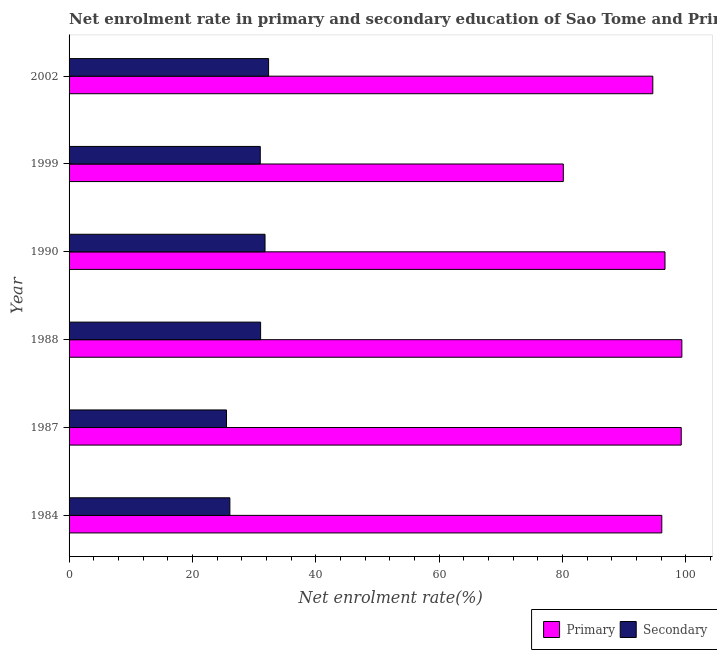How many groups of bars are there?
Offer a terse response. 6. How many bars are there on the 2nd tick from the top?
Your response must be concise. 2. In how many cases, is the number of bars for a given year not equal to the number of legend labels?
Keep it short and to the point. 0. What is the enrollment rate in secondary education in 1990?
Your response must be concise. 31.78. Across all years, what is the maximum enrollment rate in primary education?
Your response must be concise. 99.38. Across all years, what is the minimum enrollment rate in primary education?
Provide a succinct answer. 80.15. In which year was the enrollment rate in secondary education minimum?
Ensure brevity in your answer.  1987. What is the total enrollment rate in secondary education in the graph?
Offer a terse response. 177.82. What is the difference between the enrollment rate in primary education in 1984 and that in 1988?
Your response must be concise. -3.25. What is the difference between the enrollment rate in secondary education in 1984 and the enrollment rate in primary education in 1987?
Offer a terse response. -73.2. What is the average enrollment rate in secondary education per year?
Your answer should be compact. 29.64. In the year 1984, what is the difference between the enrollment rate in primary education and enrollment rate in secondary education?
Provide a succinct answer. 70.05. Is the enrollment rate in primary education in 1984 less than that in 1990?
Ensure brevity in your answer.  Yes. Is the difference between the enrollment rate in secondary education in 1990 and 1999 greater than the difference between the enrollment rate in primary education in 1990 and 1999?
Offer a terse response. No. What is the difference between the highest and the lowest enrollment rate in secondary education?
Your response must be concise. 6.83. What does the 2nd bar from the top in 1990 represents?
Offer a very short reply. Primary. What does the 2nd bar from the bottom in 1984 represents?
Offer a very short reply. Secondary. How many years are there in the graph?
Keep it short and to the point. 6. What is the difference between two consecutive major ticks on the X-axis?
Your response must be concise. 20. Does the graph contain any zero values?
Provide a succinct answer. No. Does the graph contain grids?
Ensure brevity in your answer.  No. How are the legend labels stacked?
Your answer should be compact. Horizontal. What is the title of the graph?
Offer a very short reply. Net enrolment rate in primary and secondary education of Sao Tome and Principe. Does "Girls" appear as one of the legend labels in the graph?
Ensure brevity in your answer.  No. What is the label or title of the X-axis?
Provide a succinct answer. Net enrolment rate(%). What is the label or title of the Y-axis?
Your answer should be compact. Year. What is the Net enrolment rate(%) in Primary in 1984?
Provide a short and direct response. 96.13. What is the Net enrolment rate(%) in Secondary in 1984?
Offer a very short reply. 26.08. What is the Net enrolment rate(%) of Primary in 1987?
Your response must be concise. 99.28. What is the Net enrolment rate(%) in Secondary in 1987?
Give a very brief answer. 25.53. What is the Net enrolment rate(%) in Primary in 1988?
Your answer should be compact. 99.38. What is the Net enrolment rate(%) of Secondary in 1988?
Keep it short and to the point. 31.06. What is the Net enrolment rate(%) of Primary in 1990?
Make the answer very short. 96.65. What is the Net enrolment rate(%) of Secondary in 1990?
Make the answer very short. 31.78. What is the Net enrolment rate(%) of Primary in 1999?
Keep it short and to the point. 80.15. What is the Net enrolment rate(%) of Secondary in 1999?
Keep it short and to the point. 31.01. What is the Net enrolment rate(%) of Primary in 2002?
Offer a terse response. 94.67. What is the Net enrolment rate(%) in Secondary in 2002?
Offer a very short reply. 32.36. Across all years, what is the maximum Net enrolment rate(%) in Primary?
Give a very brief answer. 99.38. Across all years, what is the maximum Net enrolment rate(%) in Secondary?
Offer a very short reply. 32.36. Across all years, what is the minimum Net enrolment rate(%) in Primary?
Provide a succinct answer. 80.15. Across all years, what is the minimum Net enrolment rate(%) of Secondary?
Provide a succinct answer. 25.53. What is the total Net enrolment rate(%) in Primary in the graph?
Offer a very short reply. 566.25. What is the total Net enrolment rate(%) in Secondary in the graph?
Offer a terse response. 177.82. What is the difference between the Net enrolment rate(%) in Primary in 1984 and that in 1987?
Offer a very short reply. -3.15. What is the difference between the Net enrolment rate(%) of Secondary in 1984 and that in 1987?
Offer a very short reply. 0.55. What is the difference between the Net enrolment rate(%) in Primary in 1984 and that in 1988?
Make the answer very short. -3.25. What is the difference between the Net enrolment rate(%) of Secondary in 1984 and that in 1988?
Ensure brevity in your answer.  -4.98. What is the difference between the Net enrolment rate(%) of Primary in 1984 and that in 1990?
Provide a short and direct response. -0.52. What is the difference between the Net enrolment rate(%) in Secondary in 1984 and that in 1990?
Make the answer very short. -5.7. What is the difference between the Net enrolment rate(%) in Primary in 1984 and that in 1999?
Provide a short and direct response. 15.97. What is the difference between the Net enrolment rate(%) in Secondary in 1984 and that in 1999?
Provide a short and direct response. -4.93. What is the difference between the Net enrolment rate(%) in Primary in 1984 and that in 2002?
Your answer should be very brief. 1.46. What is the difference between the Net enrolment rate(%) of Secondary in 1984 and that in 2002?
Keep it short and to the point. -6.28. What is the difference between the Net enrolment rate(%) in Primary in 1987 and that in 1988?
Your answer should be compact. -0.1. What is the difference between the Net enrolment rate(%) in Secondary in 1987 and that in 1988?
Offer a terse response. -5.53. What is the difference between the Net enrolment rate(%) of Primary in 1987 and that in 1990?
Offer a very short reply. 2.63. What is the difference between the Net enrolment rate(%) of Secondary in 1987 and that in 1990?
Provide a succinct answer. -6.25. What is the difference between the Net enrolment rate(%) of Primary in 1987 and that in 1999?
Your answer should be very brief. 19.13. What is the difference between the Net enrolment rate(%) in Secondary in 1987 and that in 1999?
Offer a very short reply. -5.48. What is the difference between the Net enrolment rate(%) of Primary in 1987 and that in 2002?
Your response must be concise. 4.61. What is the difference between the Net enrolment rate(%) in Secondary in 1987 and that in 2002?
Your response must be concise. -6.83. What is the difference between the Net enrolment rate(%) in Primary in 1988 and that in 1990?
Make the answer very short. 2.73. What is the difference between the Net enrolment rate(%) of Secondary in 1988 and that in 1990?
Give a very brief answer. -0.72. What is the difference between the Net enrolment rate(%) in Primary in 1988 and that in 1999?
Offer a terse response. 19.22. What is the difference between the Net enrolment rate(%) of Secondary in 1988 and that in 1999?
Give a very brief answer. 0.05. What is the difference between the Net enrolment rate(%) of Primary in 1988 and that in 2002?
Your answer should be compact. 4.71. What is the difference between the Net enrolment rate(%) in Secondary in 1988 and that in 2002?
Your answer should be very brief. -1.3. What is the difference between the Net enrolment rate(%) of Primary in 1990 and that in 1999?
Offer a terse response. 16.49. What is the difference between the Net enrolment rate(%) in Secondary in 1990 and that in 1999?
Make the answer very short. 0.77. What is the difference between the Net enrolment rate(%) in Primary in 1990 and that in 2002?
Offer a very short reply. 1.98. What is the difference between the Net enrolment rate(%) in Secondary in 1990 and that in 2002?
Your answer should be very brief. -0.58. What is the difference between the Net enrolment rate(%) in Primary in 1999 and that in 2002?
Offer a terse response. -14.52. What is the difference between the Net enrolment rate(%) of Secondary in 1999 and that in 2002?
Make the answer very short. -1.35. What is the difference between the Net enrolment rate(%) in Primary in 1984 and the Net enrolment rate(%) in Secondary in 1987?
Provide a short and direct response. 70.6. What is the difference between the Net enrolment rate(%) in Primary in 1984 and the Net enrolment rate(%) in Secondary in 1988?
Offer a very short reply. 65.06. What is the difference between the Net enrolment rate(%) of Primary in 1984 and the Net enrolment rate(%) of Secondary in 1990?
Your response must be concise. 64.35. What is the difference between the Net enrolment rate(%) in Primary in 1984 and the Net enrolment rate(%) in Secondary in 1999?
Offer a terse response. 65.12. What is the difference between the Net enrolment rate(%) of Primary in 1984 and the Net enrolment rate(%) of Secondary in 2002?
Offer a very short reply. 63.77. What is the difference between the Net enrolment rate(%) in Primary in 1987 and the Net enrolment rate(%) in Secondary in 1988?
Offer a terse response. 68.22. What is the difference between the Net enrolment rate(%) of Primary in 1987 and the Net enrolment rate(%) of Secondary in 1990?
Your answer should be compact. 67.5. What is the difference between the Net enrolment rate(%) in Primary in 1987 and the Net enrolment rate(%) in Secondary in 1999?
Offer a terse response. 68.27. What is the difference between the Net enrolment rate(%) of Primary in 1987 and the Net enrolment rate(%) of Secondary in 2002?
Ensure brevity in your answer.  66.92. What is the difference between the Net enrolment rate(%) in Primary in 1988 and the Net enrolment rate(%) in Secondary in 1990?
Give a very brief answer. 67.6. What is the difference between the Net enrolment rate(%) of Primary in 1988 and the Net enrolment rate(%) of Secondary in 1999?
Your answer should be compact. 68.37. What is the difference between the Net enrolment rate(%) in Primary in 1988 and the Net enrolment rate(%) in Secondary in 2002?
Provide a succinct answer. 67.02. What is the difference between the Net enrolment rate(%) of Primary in 1990 and the Net enrolment rate(%) of Secondary in 1999?
Offer a very short reply. 65.64. What is the difference between the Net enrolment rate(%) of Primary in 1990 and the Net enrolment rate(%) of Secondary in 2002?
Keep it short and to the point. 64.29. What is the difference between the Net enrolment rate(%) in Primary in 1999 and the Net enrolment rate(%) in Secondary in 2002?
Offer a terse response. 47.8. What is the average Net enrolment rate(%) of Primary per year?
Give a very brief answer. 94.37. What is the average Net enrolment rate(%) of Secondary per year?
Your answer should be very brief. 29.64. In the year 1984, what is the difference between the Net enrolment rate(%) in Primary and Net enrolment rate(%) in Secondary?
Your answer should be compact. 70.05. In the year 1987, what is the difference between the Net enrolment rate(%) in Primary and Net enrolment rate(%) in Secondary?
Make the answer very short. 73.75. In the year 1988, what is the difference between the Net enrolment rate(%) of Primary and Net enrolment rate(%) of Secondary?
Offer a very short reply. 68.32. In the year 1990, what is the difference between the Net enrolment rate(%) of Primary and Net enrolment rate(%) of Secondary?
Offer a terse response. 64.87. In the year 1999, what is the difference between the Net enrolment rate(%) in Primary and Net enrolment rate(%) in Secondary?
Your answer should be very brief. 49.14. In the year 2002, what is the difference between the Net enrolment rate(%) of Primary and Net enrolment rate(%) of Secondary?
Keep it short and to the point. 62.31. What is the ratio of the Net enrolment rate(%) of Primary in 1984 to that in 1987?
Your response must be concise. 0.97. What is the ratio of the Net enrolment rate(%) of Secondary in 1984 to that in 1987?
Offer a very short reply. 1.02. What is the ratio of the Net enrolment rate(%) in Primary in 1984 to that in 1988?
Make the answer very short. 0.97. What is the ratio of the Net enrolment rate(%) in Secondary in 1984 to that in 1988?
Give a very brief answer. 0.84. What is the ratio of the Net enrolment rate(%) in Primary in 1984 to that in 1990?
Keep it short and to the point. 0.99. What is the ratio of the Net enrolment rate(%) in Secondary in 1984 to that in 1990?
Ensure brevity in your answer.  0.82. What is the ratio of the Net enrolment rate(%) in Primary in 1984 to that in 1999?
Offer a terse response. 1.2. What is the ratio of the Net enrolment rate(%) in Secondary in 1984 to that in 1999?
Offer a very short reply. 0.84. What is the ratio of the Net enrolment rate(%) of Primary in 1984 to that in 2002?
Offer a terse response. 1.02. What is the ratio of the Net enrolment rate(%) of Secondary in 1984 to that in 2002?
Your answer should be very brief. 0.81. What is the ratio of the Net enrolment rate(%) in Primary in 1987 to that in 1988?
Your answer should be very brief. 1. What is the ratio of the Net enrolment rate(%) of Secondary in 1987 to that in 1988?
Give a very brief answer. 0.82. What is the ratio of the Net enrolment rate(%) of Primary in 1987 to that in 1990?
Ensure brevity in your answer.  1.03. What is the ratio of the Net enrolment rate(%) of Secondary in 1987 to that in 1990?
Ensure brevity in your answer.  0.8. What is the ratio of the Net enrolment rate(%) in Primary in 1987 to that in 1999?
Your answer should be very brief. 1.24. What is the ratio of the Net enrolment rate(%) of Secondary in 1987 to that in 1999?
Ensure brevity in your answer.  0.82. What is the ratio of the Net enrolment rate(%) of Primary in 1987 to that in 2002?
Your answer should be very brief. 1.05. What is the ratio of the Net enrolment rate(%) of Secondary in 1987 to that in 2002?
Make the answer very short. 0.79. What is the ratio of the Net enrolment rate(%) of Primary in 1988 to that in 1990?
Offer a very short reply. 1.03. What is the ratio of the Net enrolment rate(%) in Secondary in 1988 to that in 1990?
Give a very brief answer. 0.98. What is the ratio of the Net enrolment rate(%) in Primary in 1988 to that in 1999?
Make the answer very short. 1.24. What is the ratio of the Net enrolment rate(%) in Secondary in 1988 to that in 1999?
Give a very brief answer. 1. What is the ratio of the Net enrolment rate(%) of Primary in 1988 to that in 2002?
Provide a succinct answer. 1.05. What is the ratio of the Net enrolment rate(%) in Secondary in 1988 to that in 2002?
Ensure brevity in your answer.  0.96. What is the ratio of the Net enrolment rate(%) of Primary in 1990 to that in 1999?
Keep it short and to the point. 1.21. What is the ratio of the Net enrolment rate(%) in Secondary in 1990 to that in 1999?
Provide a short and direct response. 1.02. What is the ratio of the Net enrolment rate(%) of Primary in 1990 to that in 2002?
Provide a succinct answer. 1.02. What is the ratio of the Net enrolment rate(%) of Secondary in 1990 to that in 2002?
Your response must be concise. 0.98. What is the ratio of the Net enrolment rate(%) in Primary in 1999 to that in 2002?
Provide a short and direct response. 0.85. What is the difference between the highest and the second highest Net enrolment rate(%) of Primary?
Make the answer very short. 0.1. What is the difference between the highest and the second highest Net enrolment rate(%) in Secondary?
Provide a short and direct response. 0.58. What is the difference between the highest and the lowest Net enrolment rate(%) in Primary?
Make the answer very short. 19.22. What is the difference between the highest and the lowest Net enrolment rate(%) in Secondary?
Your answer should be compact. 6.83. 